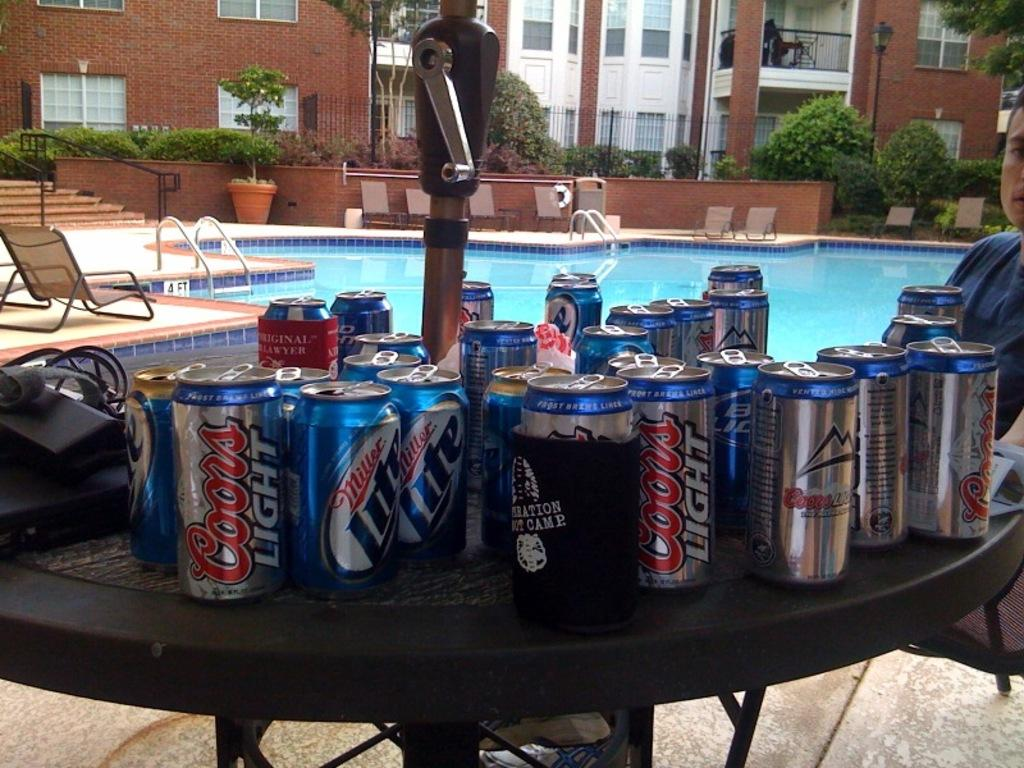Provide a one-sentence caption for the provided image. A table full of empty cans of Coors Light and Miller Lite. 